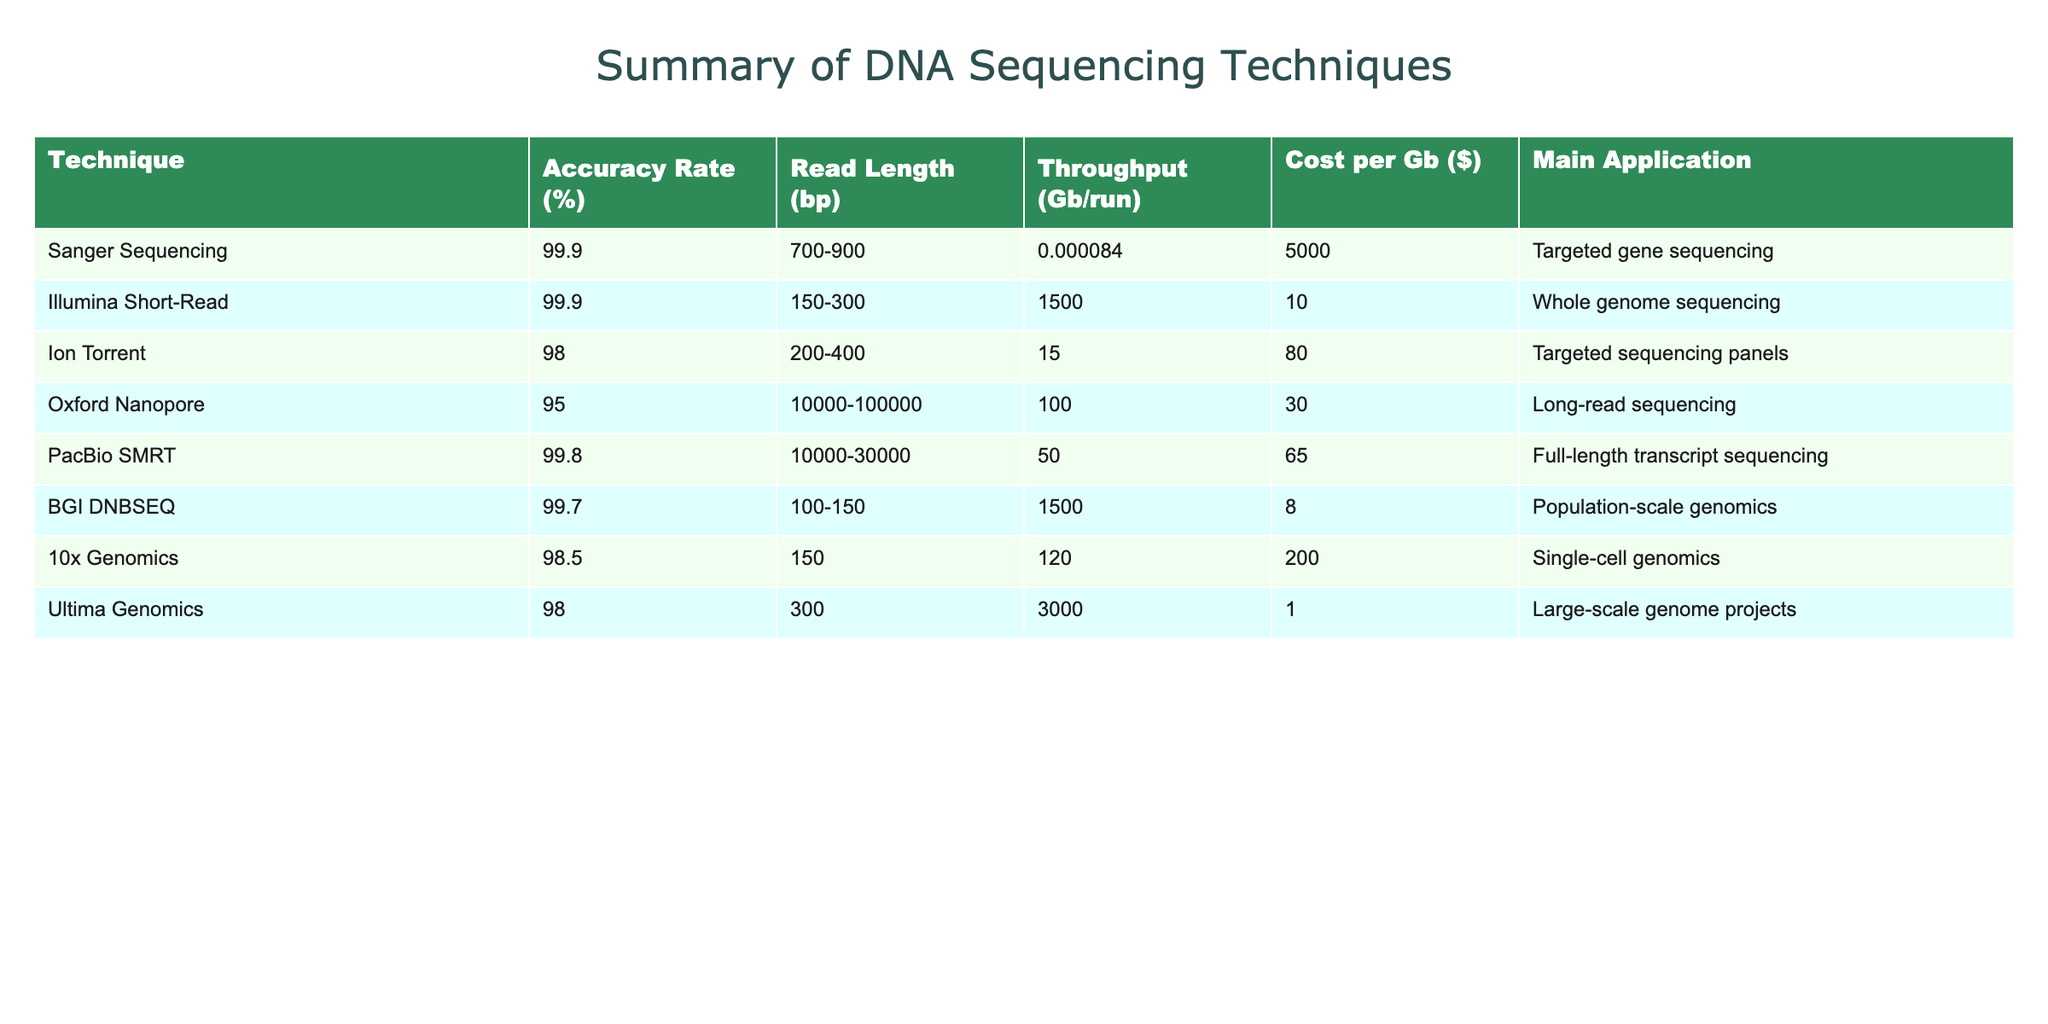What is the accuracy rate of Sanger Sequencing? The table shows that the accuracy rate for Sanger Sequencing is indicated in the second column. It states that the accuracy rate is 99.9%.
Answer: 99.9 Which sequencing technique has the longest read length? By comparing the "Read Length" column for each technique in the table, Oxford Nanopore and PacBio SMRT both have long read lengths in the range of 10,000 to 100,000 bp and 10,000 to 30,000 bp respectively. Thus, to find the longest, we see Oxford Nanopore has the widest range.
Answer: Oxford Nanopore What is the cost per Gb of BGI DNBSEQ? The cost per Gb for BGI DNBSEQ is stated in the last column of the table, which shows a value of 8.
Answer: 8 Which sequencing technique is primarily used for single-cell genomics? The application specified for each method in the "Main Application" column identifies 10x Genomics as the technique mainly used for single-cell genomics.
Answer: 10x Genomics What is the average accuracy rate of the techniques listed? The accuracy rates in the table, listed as 99.9, 99.9, 98.0, 95.0, 99.8, 99.7, 98.5, and 98.0, when summed gives 792.8. Since there are 8 techniques, the average accuracy rate is 792.8/8 = 99.1.
Answer: 99.1 Is the cost per Gb of Ion Torrent less than or equal to that of PacBio SMRT? Checking the cost per Gb in the respective rows of the table, Ion Torrent is at 80 while PacBio SMRT is at 65. Since 80 is not less than or equal to 65, the statement is false.
Answer: False What technique has the highest throughput per run? In the "Throughput" column, Illumina Short-Read and BGI DNBSEQ both have a throughput of 1500 Gb/run, which is the highest among all techniques.
Answer: Illumina Short-Read and BGI DNBSEQ Which sequencing technique has the lowest accuracy rate? By reviewing the "Accuracy Rate" column in the table, Oxford Nanopore has the lowest accuracy rate at 95.0% compared to others listed.
Answer: Oxford Nanopore If you were to compare the cost per Gb of PacBio SMRT and Ultima Genomics, which is less expensive? Comparing the values in the "Cost per Gb" column, PacBio SMRT costs 65, while Ultima Genomics is significantly less at 1. Thus, Ultima Genomics is less expensive.
Answer: Ultima Genomics How many techniques have an accuracy rate of 99% or higher? Checking the "Accuracy Rate" column, the techniques with an accuracy of 99% or higher are Sanger Sequencing, Illumina Short-Read, PacBio SMRT, and BGI DNBSEQ, totaling four techniques.
Answer: 4 